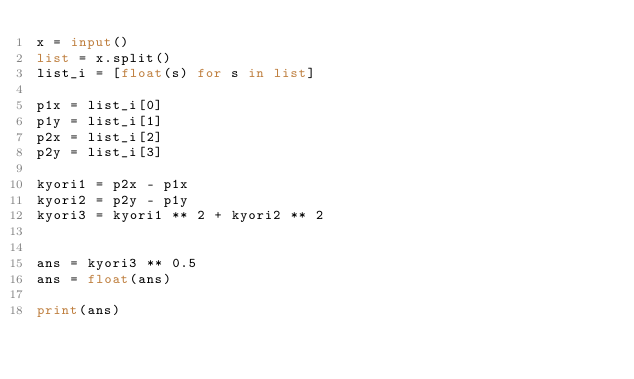Convert code to text. <code><loc_0><loc_0><loc_500><loc_500><_Python_>x = input()
list = x.split()
list_i = [float(s) for s in list]

p1x = list_i[0]
p1y = list_i[1]
p2x = list_i[2]
p2y = list_i[3]

kyori1 = p2x - p1x
kyori2 = p2y - p1y
kyori3 = kyori1 ** 2 + kyori2 ** 2


ans = kyori3 ** 0.5
ans = float(ans)

print(ans)
</code> 